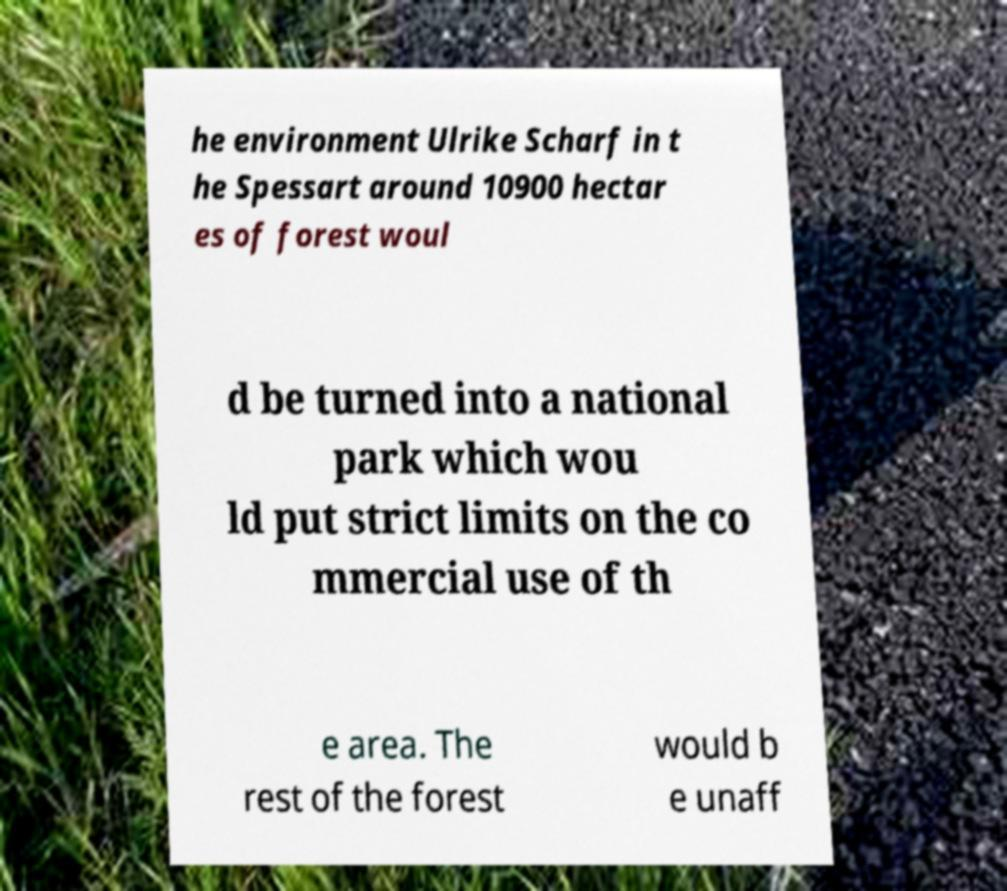Please identify and transcribe the text found in this image. he environment Ulrike Scharf in t he Spessart around 10900 hectar es of forest woul d be turned into a national park which wou ld put strict limits on the co mmercial use of th e area. The rest of the forest would b e unaff 